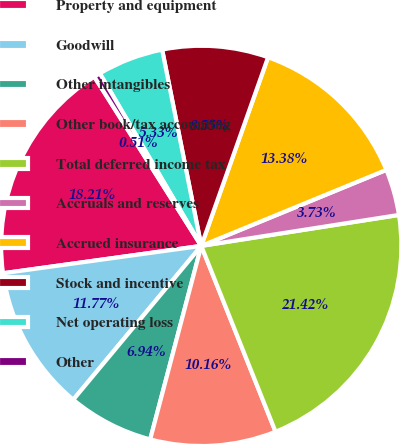<chart> <loc_0><loc_0><loc_500><loc_500><pie_chart><fcel>Property and equipment<fcel>Goodwill<fcel>Other intangibles<fcel>Other book/tax accounting<fcel>Total deferred income tax<fcel>Accruals and reserves<fcel>Accrued insurance<fcel>Stock and incentive<fcel>Net operating loss<fcel>Other<nl><fcel>18.21%<fcel>11.77%<fcel>6.94%<fcel>10.16%<fcel>21.42%<fcel>3.73%<fcel>13.38%<fcel>8.55%<fcel>5.33%<fcel>0.51%<nl></chart> 